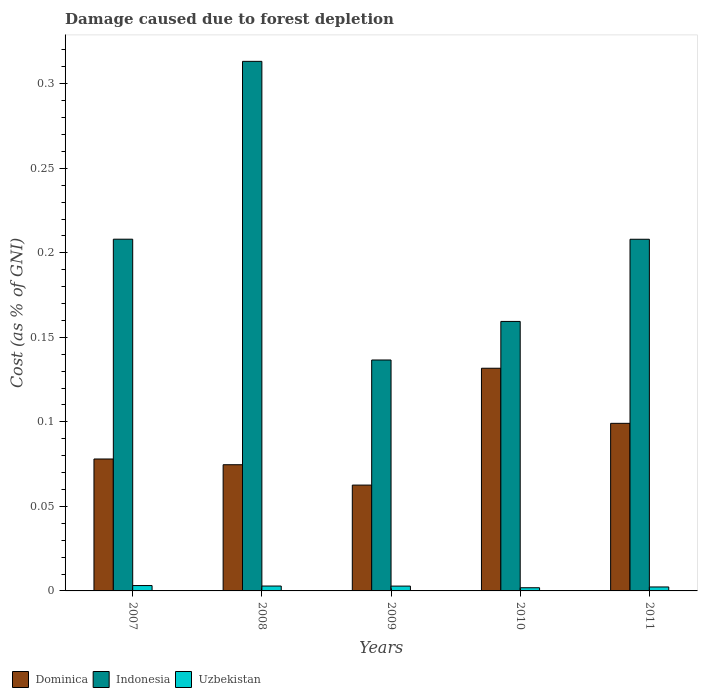Are the number of bars on each tick of the X-axis equal?
Make the answer very short. Yes. In how many cases, is the number of bars for a given year not equal to the number of legend labels?
Your answer should be very brief. 0. What is the cost of damage caused due to forest depletion in Dominica in 2009?
Provide a short and direct response. 0.06. Across all years, what is the maximum cost of damage caused due to forest depletion in Dominica?
Give a very brief answer. 0.13. Across all years, what is the minimum cost of damage caused due to forest depletion in Uzbekistan?
Offer a terse response. 0. In which year was the cost of damage caused due to forest depletion in Uzbekistan maximum?
Your answer should be very brief. 2007. What is the total cost of damage caused due to forest depletion in Uzbekistan in the graph?
Offer a very short reply. 0.01. What is the difference between the cost of damage caused due to forest depletion in Dominica in 2008 and that in 2011?
Offer a terse response. -0.02. What is the difference between the cost of damage caused due to forest depletion in Uzbekistan in 2011 and the cost of damage caused due to forest depletion in Dominica in 2007?
Make the answer very short. -0.08. What is the average cost of damage caused due to forest depletion in Uzbekistan per year?
Provide a succinct answer. 0. In the year 2008, what is the difference between the cost of damage caused due to forest depletion in Dominica and cost of damage caused due to forest depletion in Uzbekistan?
Offer a very short reply. 0.07. What is the ratio of the cost of damage caused due to forest depletion in Dominica in 2008 to that in 2011?
Keep it short and to the point. 0.75. Is the cost of damage caused due to forest depletion in Dominica in 2008 less than that in 2009?
Offer a very short reply. No. What is the difference between the highest and the second highest cost of damage caused due to forest depletion in Uzbekistan?
Provide a short and direct response. 0. What is the difference between the highest and the lowest cost of damage caused due to forest depletion in Uzbekistan?
Offer a terse response. 0. What does the 2nd bar from the left in 2007 represents?
Make the answer very short. Indonesia. What does the 2nd bar from the right in 2010 represents?
Offer a terse response. Indonesia. Is it the case that in every year, the sum of the cost of damage caused due to forest depletion in Indonesia and cost of damage caused due to forest depletion in Dominica is greater than the cost of damage caused due to forest depletion in Uzbekistan?
Give a very brief answer. Yes. How many bars are there?
Offer a very short reply. 15. Are all the bars in the graph horizontal?
Keep it short and to the point. No. What is the difference between two consecutive major ticks on the Y-axis?
Offer a terse response. 0.05. Does the graph contain grids?
Offer a very short reply. No. Where does the legend appear in the graph?
Provide a short and direct response. Bottom left. How are the legend labels stacked?
Your response must be concise. Horizontal. What is the title of the graph?
Give a very brief answer. Damage caused due to forest depletion. What is the label or title of the Y-axis?
Your answer should be very brief. Cost (as % of GNI). What is the Cost (as % of GNI) of Dominica in 2007?
Make the answer very short. 0.08. What is the Cost (as % of GNI) of Indonesia in 2007?
Your answer should be compact. 0.21. What is the Cost (as % of GNI) in Uzbekistan in 2007?
Your answer should be very brief. 0. What is the Cost (as % of GNI) in Dominica in 2008?
Make the answer very short. 0.07. What is the Cost (as % of GNI) of Indonesia in 2008?
Provide a short and direct response. 0.31. What is the Cost (as % of GNI) in Uzbekistan in 2008?
Offer a terse response. 0. What is the Cost (as % of GNI) of Dominica in 2009?
Keep it short and to the point. 0.06. What is the Cost (as % of GNI) in Indonesia in 2009?
Your answer should be very brief. 0.14. What is the Cost (as % of GNI) of Uzbekistan in 2009?
Make the answer very short. 0. What is the Cost (as % of GNI) in Dominica in 2010?
Your response must be concise. 0.13. What is the Cost (as % of GNI) in Indonesia in 2010?
Your answer should be very brief. 0.16. What is the Cost (as % of GNI) in Uzbekistan in 2010?
Provide a short and direct response. 0. What is the Cost (as % of GNI) in Dominica in 2011?
Give a very brief answer. 0.1. What is the Cost (as % of GNI) of Indonesia in 2011?
Give a very brief answer. 0.21. What is the Cost (as % of GNI) of Uzbekistan in 2011?
Offer a very short reply. 0. Across all years, what is the maximum Cost (as % of GNI) of Dominica?
Your answer should be compact. 0.13. Across all years, what is the maximum Cost (as % of GNI) of Indonesia?
Ensure brevity in your answer.  0.31. Across all years, what is the maximum Cost (as % of GNI) in Uzbekistan?
Provide a succinct answer. 0. Across all years, what is the minimum Cost (as % of GNI) in Dominica?
Keep it short and to the point. 0.06. Across all years, what is the minimum Cost (as % of GNI) of Indonesia?
Offer a very short reply. 0.14. Across all years, what is the minimum Cost (as % of GNI) in Uzbekistan?
Ensure brevity in your answer.  0. What is the total Cost (as % of GNI) of Dominica in the graph?
Ensure brevity in your answer.  0.45. What is the total Cost (as % of GNI) of Indonesia in the graph?
Offer a very short reply. 1.03. What is the total Cost (as % of GNI) in Uzbekistan in the graph?
Your answer should be very brief. 0.01. What is the difference between the Cost (as % of GNI) of Dominica in 2007 and that in 2008?
Give a very brief answer. 0. What is the difference between the Cost (as % of GNI) in Indonesia in 2007 and that in 2008?
Ensure brevity in your answer.  -0.11. What is the difference between the Cost (as % of GNI) in Dominica in 2007 and that in 2009?
Give a very brief answer. 0.02. What is the difference between the Cost (as % of GNI) in Indonesia in 2007 and that in 2009?
Keep it short and to the point. 0.07. What is the difference between the Cost (as % of GNI) in Dominica in 2007 and that in 2010?
Ensure brevity in your answer.  -0.05. What is the difference between the Cost (as % of GNI) in Indonesia in 2007 and that in 2010?
Make the answer very short. 0.05. What is the difference between the Cost (as % of GNI) of Uzbekistan in 2007 and that in 2010?
Offer a terse response. 0. What is the difference between the Cost (as % of GNI) of Dominica in 2007 and that in 2011?
Provide a succinct answer. -0.02. What is the difference between the Cost (as % of GNI) in Indonesia in 2007 and that in 2011?
Ensure brevity in your answer.  0. What is the difference between the Cost (as % of GNI) in Uzbekistan in 2007 and that in 2011?
Keep it short and to the point. 0. What is the difference between the Cost (as % of GNI) of Dominica in 2008 and that in 2009?
Your answer should be very brief. 0.01. What is the difference between the Cost (as % of GNI) of Indonesia in 2008 and that in 2009?
Your response must be concise. 0.18. What is the difference between the Cost (as % of GNI) in Dominica in 2008 and that in 2010?
Your answer should be very brief. -0.06. What is the difference between the Cost (as % of GNI) in Indonesia in 2008 and that in 2010?
Give a very brief answer. 0.15. What is the difference between the Cost (as % of GNI) in Uzbekistan in 2008 and that in 2010?
Give a very brief answer. 0. What is the difference between the Cost (as % of GNI) of Dominica in 2008 and that in 2011?
Your answer should be compact. -0.02. What is the difference between the Cost (as % of GNI) of Indonesia in 2008 and that in 2011?
Make the answer very short. 0.11. What is the difference between the Cost (as % of GNI) in Uzbekistan in 2008 and that in 2011?
Ensure brevity in your answer.  0. What is the difference between the Cost (as % of GNI) in Dominica in 2009 and that in 2010?
Ensure brevity in your answer.  -0.07. What is the difference between the Cost (as % of GNI) in Indonesia in 2009 and that in 2010?
Keep it short and to the point. -0.02. What is the difference between the Cost (as % of GNI) of Dominica in 2009 and that in 2011?
Provide a succinct answer. -0.04. What is the difference between the Cost (as % of GNI) of Indonesia in 2009 and that in 2011?
Provide a succinct answer. -0.07. What is the difference between the Cost (as % of GNI) of Uzbekistan in 2009 and that in 2011?
Make the answer very short. 0. What is the difference between the Cost (as % of GNI) in Dominica in 2010 and that in 2011?
Give a very brief answer. 0.03. What is the difference between the Cost (as % of GNI) in Indonesia in 2010 and that in 2011?
Offer a very short reply. -0.05. What is the difference between the Cost (as % of GNI) in Uzbekistan in 2010 and that in 2011?
Offer a terse response. -0. What is the difference between the Cost (as % of GNI) in Dominica in 2007 and the Cost (as % of GNI) in Indonesia in 2008?
Your answer should be compact. -0.24. What is the difference between the Cost (as % of GNI) of Dominica in 2007 and the Cost (as % of GNI) of Uzbekistan in 2008?
Make the answer very short. 0.08. What is the difference between the Cost (as % of GNI) of Indonesia in 2007 and the Cost (as % of GNI) of Uzbekistan in 2008?
Give a very brief answer. 0.21. What is the difference between the Cost (as % of GNI) of Dominica in 2007 and the Cost (as % of GNI) of Indonesia in 2009?
Give a very brief answer. -0.06. What is the difference between the Cost (as % of GNI) of Dominica in 2007 and the Cost (as % of GNI) of Uzbekistan in 2009?
Offer a very short reply. 0.08. What is the difference between the Cost (as % of GNI) of Indonesia in 2007 and the Cost (as % of GNI) of Uzbekistan in 2009?
Make the answer very short. 0.21. What is the difference between the Cost (as % of GNI) of Dominica in 2007 and the Cost (as % of GNI) of Indonesia in 2010?
Your answer should be compact. -0.08. What is the difference between the Cost (as % of GNI) in Dominica in 2007 and the Cost (as % of GNI) in Uzbekistan in 2010?
Provide a succinct answer. 0.08. What is the difference between the Cost (as % of GNI) in Indonesia in 2007 and the Cost (as % of GNI) in Uzbekistan in 2010?
Your answer should be very brief. 0.21. What is the difference between the Cost (as % of GNI) of Dominica in 2007 and the Cost (as % of GNI) of Indonesia in 2011?
Your answer should be compact. -0.13. What is the difference between the Cost (as % of GNI) of Dominica in 2007 and the Cost (as % of GNI) of Uzbekistan in 2011?
Your answer should be very brief. 0.08. What is the difference between the Cost (as % of GNI) of Indonesia in 2007 and the Cost (as % of GNI) of Uzbekistan in 2011?
Offer a terse response. 0.21. What is the difference between the Cost (as % of GNI) in Dominica in 2008 and the Cost (as % of GNI) in Indonesia in 2009?
Your response must be concise. -0.06. What is the difference between the Cost (as % of GNI) in Dominica in 2008 and the Cost (as % of GNI) in Uzbekistan in 2009?
Your answer should be compact. 0.07. What is the difference between the Cost (as % of GNI) in Indonesia in 2008 and the Cost (as % of GNI) in Uzbekistan in 2009?
Keep it short and to the point. 0.31. What is the difference between the Cost (as % of GNI) of Dominica in 2008 and the Cost (as % of GNI) of Indonesia in 2010?
Offer a very short reply. -0.08. What is the difference between the Cost (as % of GNI) in Dominica in 2008 and the Cost (as % of GNI) in Uzbekistan in 2010?
Offer a terse response. 0.07. What is the difference between the Cost (as % of GNI) in Indonesia in 2008 and the Cost (as % of GNI) in Uzbekistan in 2010?
Your answer should be very brief. 0.31. What is the difference between the Cost (as % of GNI) in Dominica in 2008 and the Cost (as % of GNI) in Indonesia in 2011?
Keep it short and to the point. -0.13. What is the difference between the Cost (as % of GNI) of Dominica in 2008 and the Cost (as % of GNI) of Uzbekistan in 2011?
Give a very brief answer. 0.07. What is the difference between the Cost (as % of GNI) in Indonesia in 2008 and the Cost (as % of GNI) in Uzbekistan in 2011?
Offer a terse response. 0.31. What is the difference between the Cost (as % of GNI) in Dominica in 2009 and the Cost (as % of GNI) in Indonesia in 2010?
Offer a terse response. -0.1. What is the difference between the Cost (as % of GNI) in Dominica in 2009 and the Cost (as % of GNI) in Uzbekistan in 2010?
Keep it short and to the point. 0.06. What is the difference between the Cost (as % of GNI) in Indonesia in 2009 and the Cost (as % of GNI) in Uzbekistan in 2010?
Give a very brief answer. 0.13. What is the difference between the Cost (as % of GNI) of Dominica in 2009 and the Cost (as % of GNI) of Indonesia in 2011?
Keep it short and to the point. -0.15. What is the difference between the Cost (as % of GNI) in Dominica in 2009 and the Cost (as % of GNI) in Uzbekistan in 2011?
Offer a terse response. 0.06. What is the difference between the Cost (as % of GNI) of Indonesia in 2009 and the Cost (as % of GNI) of Uzbekistan in 2011?
Make the answer very short. 0.13. What is the difference between the Cost (as % of GNI) in Dominica in 2010 and the Cost (as % of GNI) in Indonesia in 2011?
Your response must be concise. -0.08. What is the difference between the Cost (as % of GNI) in Dominica in 2010 and the Cost (as % of GNI) in Uzbekistan in 2011?
Provide a short and direct response. 0.13. What is the difference between the Cost (as % of GNI) in Indonesia in 2010 and the Cost (as % of GNI) in Uzbekistan in 2011?
Provide a succinct answer. 0.16. What is the average Cost (as % of GNI) of Dominica per year?
Ensure brevity in your answer.  0.09. What is the average Cost (as % of GNI) in Indonesia per year?
Offer a very short reply. 0.21. What is the average Cost (as % of GNI) of Uzbekistan per year?
Your response must be concise. 0. In the year 2007, what is the difference between the Cost (as % of GNI) of Dominica and Cost (as % of GNI) of Indonesia?
Provide a succinct answer. -0.13. In the year 2007, what is the difference between the Cost (as % of GNI) in Dominica and Cost (as % of GNI) in Uzbekistan?
Make the answer very short. 0.07. In the year 2007, what is the difference between the Cost (as % of GNI) of Indonesia and Cost (as % of GNI) of Uzbekistan?
Offer a very short reply. 0.2. In the year 2008, what is the difference between the Cost (as % of GNI) of Dominica and Cost (as % of GNI) of Indonesia?
Ensure brevity in your answer.  -0.24. In the year 2008, what is the difference between the Cost (as % of GNI) in Dominica and Cost (as % of GNI) in Uzbekistan?
Provide a short and direct response. 0.07. In the year 2008, what is the difference between the Cost (as % of GNI) of Indonesia and Cost (as % of GNI) of Uzbekistan?
Provide a short and direct response. 0.31. In the year 2009, what is the difference between the Cost (as % of GNI) in Dominica and Cost (as % of GNI) in Indonesia?
Offer a very short reply. -0.07. In the year 2009, what is the difference between the Cost (as % of GNI) in Dominica and Cost (as % of GNI) in Uzbekistan?
Give a very brief answer. 0.06. In the year 2009, what is the difference between the Cost (as % of GNI) in Indonesia and Cost (as % of GNI) in Uzbekistan?
Your answer should be very brief. 0.13. In the year 2010, what is the difference between the Cost (as % of GNI) of Dominica and Cost (as % of GNI) of Indonesia?
Your answer should be very brief. -0.03. In the year 2010, what is the difference between the Cost (as % of GNI) of Dominica and Cost (as % of GNI) of Uzbekistan?
Provide a succinct answer. 0.13. In the year 2010, what is the difference between the Cost (as % of GNI) of Indonesia and Cost (as % of GNI) of Uzbekistan?
Give a very brief answer. 0.16. In the year 2011, what is the difference between the Cost (as % of GNI) in Dominica and Cost (as % of GNI) in Indonesia?
Give a very brief answer. -0.11. In the year 2011, what is the difference between the Cost (as % of GNI) of Dominica and Cost (as % of GNI) of Uzbekistan?
Give a very brief answer. 0.1. In the year 2011, what is the difference between the Cost (as % of GNI) in Indonesia and Cost (as % of GNI) in Uzbekistan?
Make the answer very short. 0.21. What is the ratio of the Cost (as % of GNI) in Dominica in 2007 to that in 2008?
Ensure brevity in your answer.  1.05. What is the ratio of the Cost (as % of GNI) of Indonesia in 2007 to that in 2008?
Offer a very short reply. 0.66. What is the ratio of the Cost (as % of GNI) in Uzbekistan in 2007 to that in 2008?
Your response must be concise. 1.1. What is the ratio of the Cost (as % of GNI) in Dominica in 2007 to that in 2009?
Offer a terse response. 1.25. What is the ratio of the Cost (as % of GNI) of Indonesia in 2007 to that in 2009?
Give a very brief answer. 1.52. What is the ratio of the Cost (as % of GNI) in Uzbekistan in 2007 to that in 2009?
Ensure brevity in your answer.  1.11. What is the ratio of the Cost (as % of GNI) in Dominica in 2007 to that in 2010?
Your response must be concise. 0.59. What is the ratio of the Cost (as % of GNI) in Indonesia in 2007 to that in 2010?
Provide a succinct answer. 1.31. What is the ratio of the Cost (as % of GNI) of Uzbekistan in 2007 to that in 2010?
Your answer should be very brief. 1.69. What is the ratio of the Cost (as % of GNI) in Dominica in 2007 to that in 2011?
Give a very brief answer. 0.79. What is the ratio of the Cost (as % of GNI) of Indonesia in 2007 to that in 2011?
Offer a terse response. 1. What is the ratio of the Cost (as % of GNI) in Uzbekistan in 2007 to that in 2011?
Ensure brevity in your answer.  1.35. What is the ratio of the Cost (as % of GNI) of Dominica in 2008 to that in 2009?
Provide a succinct answer. 1.19. What is the ratio of the Cost (as % of GNI) in Indonesia in 2008 to that in 2009?
Offer a very short reply. 2.29. What is the ratio of the Cost (as % of GNI) in Uzbekistan in 2008 to that in 2009?
Your answer should be very brief. 1.01. What is the ratio of the Cost (as % of GNI) in Dominica in 2008 to that in 2010?
Ensure brevity in your answer.  0.57. What is the ratio of the Cost (as % of GNI) of Indonesia in 2008 to that in 2010?
Your answer should be very brief. 1.97. What is the ratio of the Cost (as % of GNI) of Uzbekistan in 2008 to that in 2010?
Make the answer very short. 1.54. What is the ratio of the Cost (as % of GNI) of Dominica in 2008 to that in 2011?
Offer a terse response. 0.75. What is the ratio of the Cost (as % of GNI) in Indonesia in 2008 to that in 2011?
Your answer should be compact. 1.51. What is the ratio of the Cost (as % of GNI) in Uzbekistan in 2008 to that in 2011?
Ensure brevity in your answer.  1.23. What is the ratio of the Cost (as % of GNI) in Dominica in 2009 to that in 2010?
Keep it short and to the point. 0.48. What is the ratio of the Cost (as % of GNI) of Indonesia in 2009 to that in 2010?
Your response must be concise. 0.86. What is the ratio of the Cost (as % of GNI) in Uzbekistan in 2009 to that in 2010?
Your response must be concise. 1.52. What is the ratio of the Cost (as % of GNI) of Dominica in 2009 to that in 2011?
Provide a succinct answer. 0.63. What is the ratio of the Cost (as % of GNI) of Indonesia in 2009 to that in 2011?
Give a very brief answer. 0.66. What is the ratio of the Cost (as % of GNI) in Uzbekistan in 2009 to that in 2011?
Your answer should be very brief. 1.22. What is the ratio of the Cost (as % of GNI) of Dominica in 2010 to that in 2011?
Give a very brief answer. 1.33. What is the ratio of the Cost (as % of GNI) in Indonesia in 2010 to that in 2011?
Provide a succinct answer. 0.77. What is the ratio of the Cost (as % of GNI) of Uzbekistan in 2010 to that in 2011?
Your answer should be compact. 0.8. What is the difference between the highest and the second highest Cost (as % of GNI) of Dominica?
Offer a terse response. 0.03. What is the difference between the highest and the second highest Cost (as % of GNI) of Indonesia?
Offer a very short reply. 0.11. What is the difference between the highest and the second highest Cost (as % of GNI) of Uzbekistan?
Your answer should be compact. 0. What is the difference between the highest and the lowest Cost (as % of GNI) of Dominica?
Make the answer very short. 0.07. What is the difference between the highest and the lowest Cost (as % of GNI) of Indonesia?
Keep it short and to the point. 0.18. What is the difference between the highest and the lowest Cost (as % of GNI) in Uzbekistan?
Give a very brief answer. 0. 